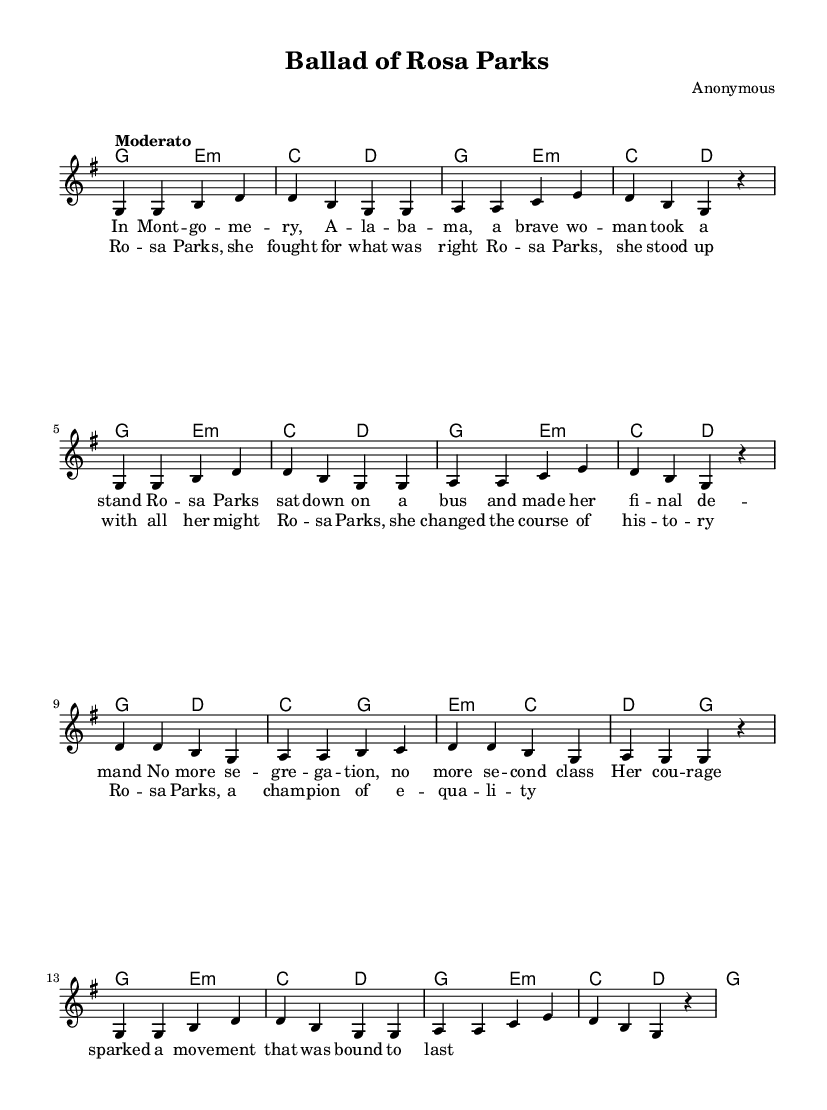What is the key signature of this music? The key signature indicated in the sheet music is G major, which includes one sharp (F#).
Answer: G major What is the time signature used in this song? The time signature is 4/4, which means there are four beats per measure. This is visible at the beginning of the score.
Answer: 4/4 What is the tempo marking for this piece? The tempo marking is "Moderato", implying a moderate speed. This is placed at the start of the score.
Answer: Moderato How many verses are in the lyrics provided? There is one verse section followed by a chorus section, meaning there is notably one complete verse presented in the music.
Answer: One What historical figure is this song about? The lyrics prominently feature Rosa Parks as the subject, highlighting her actions in the civil rights movement. This is clearly indicated in the chorus.
Answer: Rosa Parks What is the primary theme conveyed in the lyrics? The primary theme of the lyrics is civil rights and equality, as it celebrates Rosa Parks' fight against segregation. This theme can be inferred from both the verse and chorus content.
Answer: Equality How many lines are in the chorus? The chorus composes four lines of lyrics, clearly outlined with stanza breaks. This can be seen both in the formatted lyrics section and the overall layout.
Answer: Four 